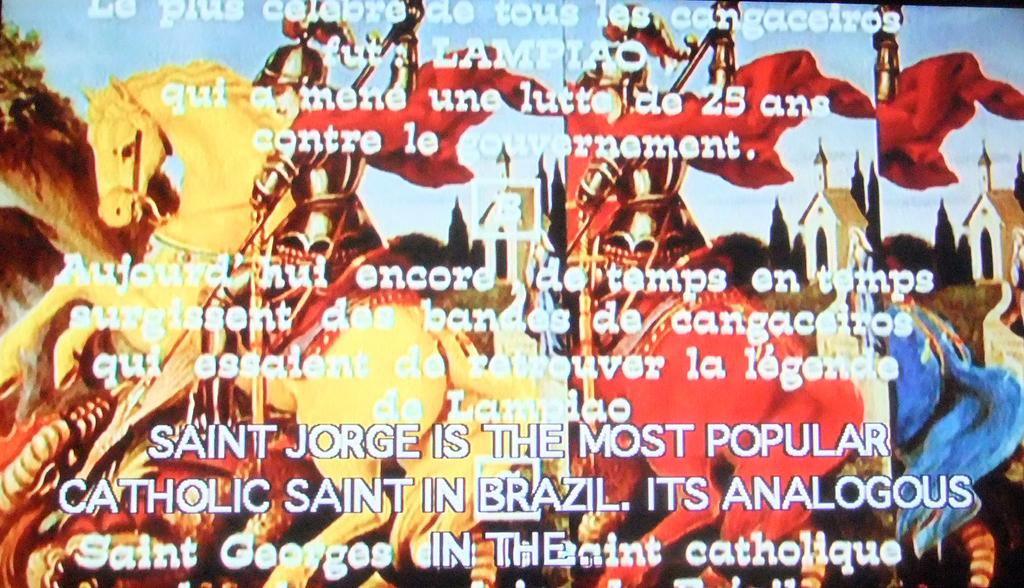<image>
Relay a brief, clear account of the picture shown. a colorful photo of horses with Catholic on it 